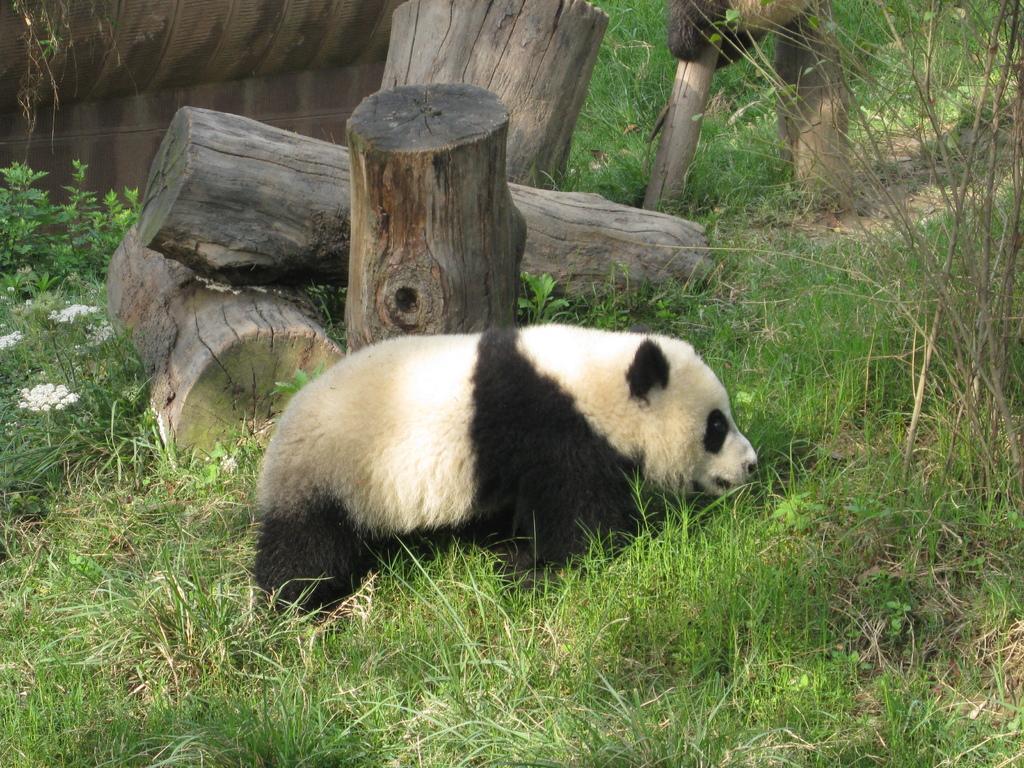Please provide a concise description of this image. In the image there is a panda laying on a grass and behind the panda there are few wooden logs. 